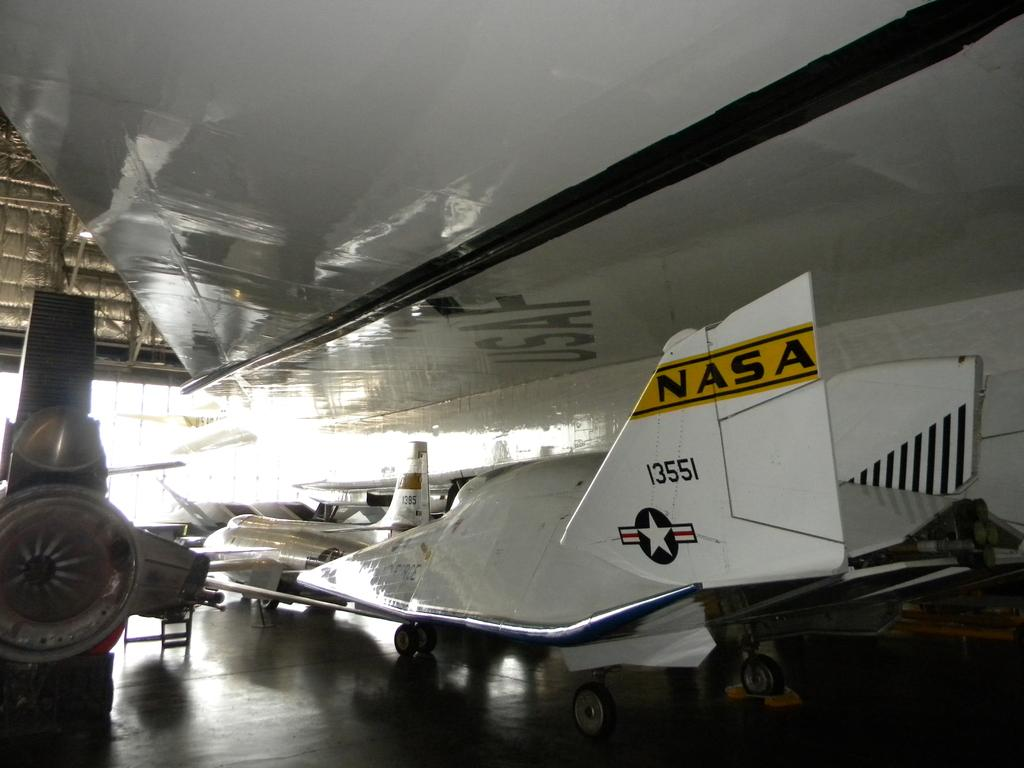Provide a one-sentence caption for the provided image. The view of the underside of a USAF plane's wing. 